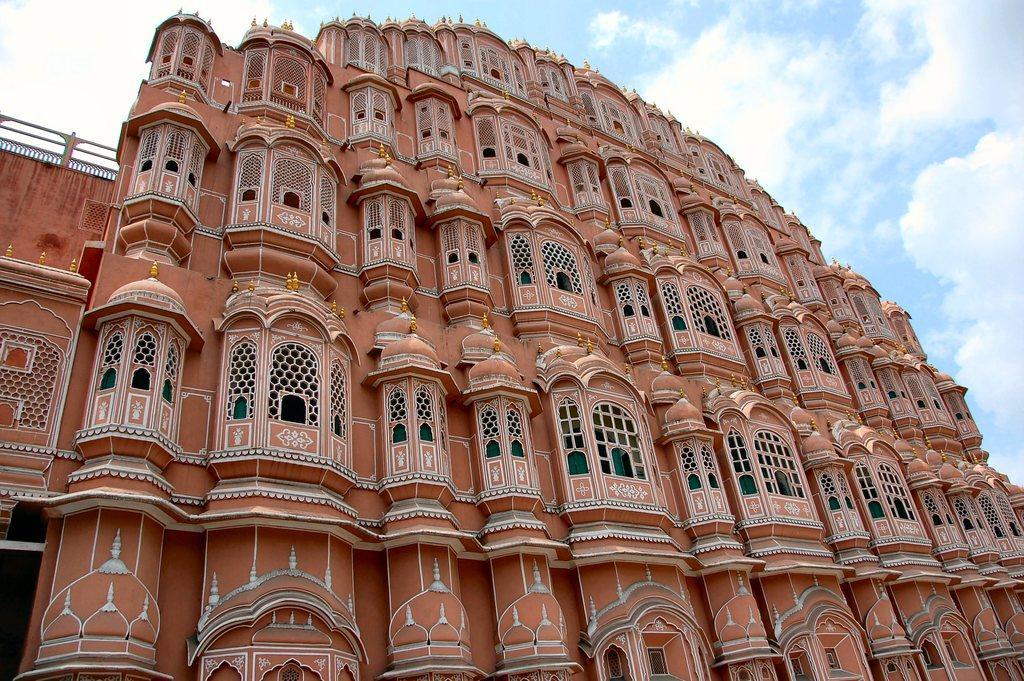Describe this image in one or two sentences. In this image in the front there is a building and the sky is cloudy. 